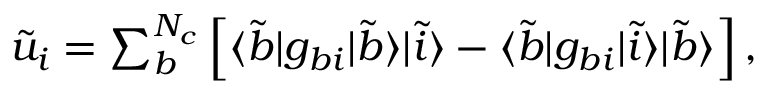Convert formula to latex. <formula><loc_0><loc_0><loc_500><loc_500>\begin{array} { r } { \tilde { u } _ { i } = \sum _ { b } ^ { N _ { c } } \left [ \langle \tilde { b } | g _ { b i } | \tilde { b } \rangle | \tilde { i } \rangle - \langle \tilde { b } | g _ { b i } | \tilde { i } \rangle | \tilde { b } \rangle \right ] , } \end{array}</formula> 